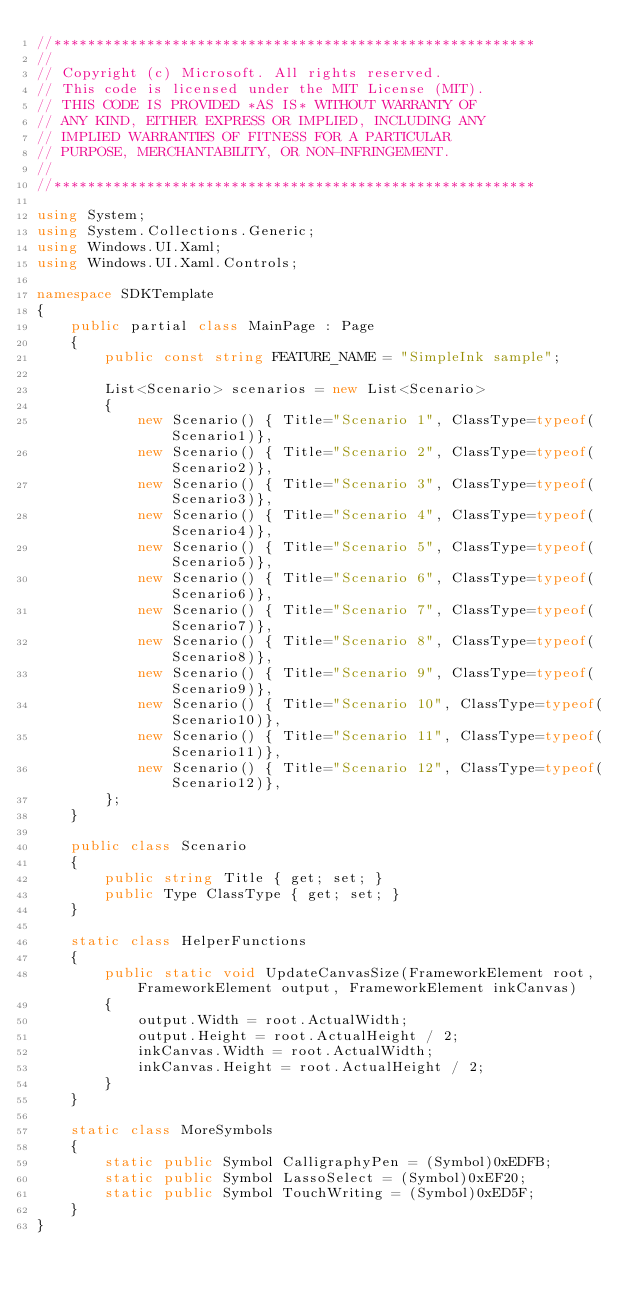Convert code to text. <code><loc_0><loc_0><loc_500><loc_500><_C#_>//*********************************************************
//
// Copyright (c) Microsoft. All rights reserved.
// This code is licensed under the MIT License (MIT).
// THIS CODE IS PROVIDED *AS IS* WITHOUT WARRANTY OF
// ANY KIND, EITHER EXPRESS OR IMPLIED, INCLUDING ANY
// IMPLIED WARRANTIES OF FITNESS FOR A PARTICULAR
// PURPOSE, MERCHANTABILITY, OR NON-INFRINGEMENT.
//
//*********************************************************

using System;
using System.Collections.Generic;
using Windows.UI.Xaml;
using Windows.UI.Xaml.Controls;

namespace SDKTemplate
{
    public partial class MainPage : Page
    {
        public const string FEATURE_NAME = "SimpleInk sample";

        List<Scenario> scenarios = new List<Scenario>
        {
            new Scenario() { Title="Scenario 1", ClassType=typeof(Scenario1)},
            new Scenario() { Title="Scenario 2", ClassType=typeof(Scenario2)},
            new Scenario() { Title="Scenario 3", ClassType=typeof(Scenario3)},
            new Scenario() { Title="Scenario 4", ClassType=typeof(Scenario4)},
            new Scenario() { Title="Scenario 5", ClassType=typeof(Scenario5)},
            new Scenario() { Title="Scenario 6", ClassType=typeof(Scenario6)},
            new Scenario() { Title="Scenario 7", ClassType=typeof(Scenario7)},
            new Scenario() { Title="Scenario 8", ClassType=typeof(Scenario8)},
            new Scenario() { Title="Scenario 9", ClassType=typeof(Scenario9)},
            new Scenario() { Title="Scenario 10", ClassType=typeof(Scenario10)},
            new Scenario() { Title="Scenario 11", ClassType=typeof(Scenario11)},
            new Scenario() { Title="Scenario 12", ClassType=typeof(Scenario12)},
        };
    }

    public class Scenario
    {
        public string Title { get; set; }
        public Type ClassType { get; set; }
    }

    static class HelperFunctions
    {
        public static void UpdateCanvasSize(FrameworkElement root, FrameworkElement output, FrameworkElement inkCanvas)
        {
            output.Width = root.ActualWidth;
            output.Height = root.ActualHeight / 2;
            inkCanvas.Width = root.ActualWidth;
            inkCanvas.Height = root.ActualHeight / 2;
        }
    }

    static class MoreSymbols
    {
        static public Symbol CalligraphyPen = (Symbol)0xEDFB;
        static public Symbol LassoSelect = (Symbol)0xEF20;
        static public Symbol TouchWriting = (Symbol)0xED5F;
    }
}
</code> 